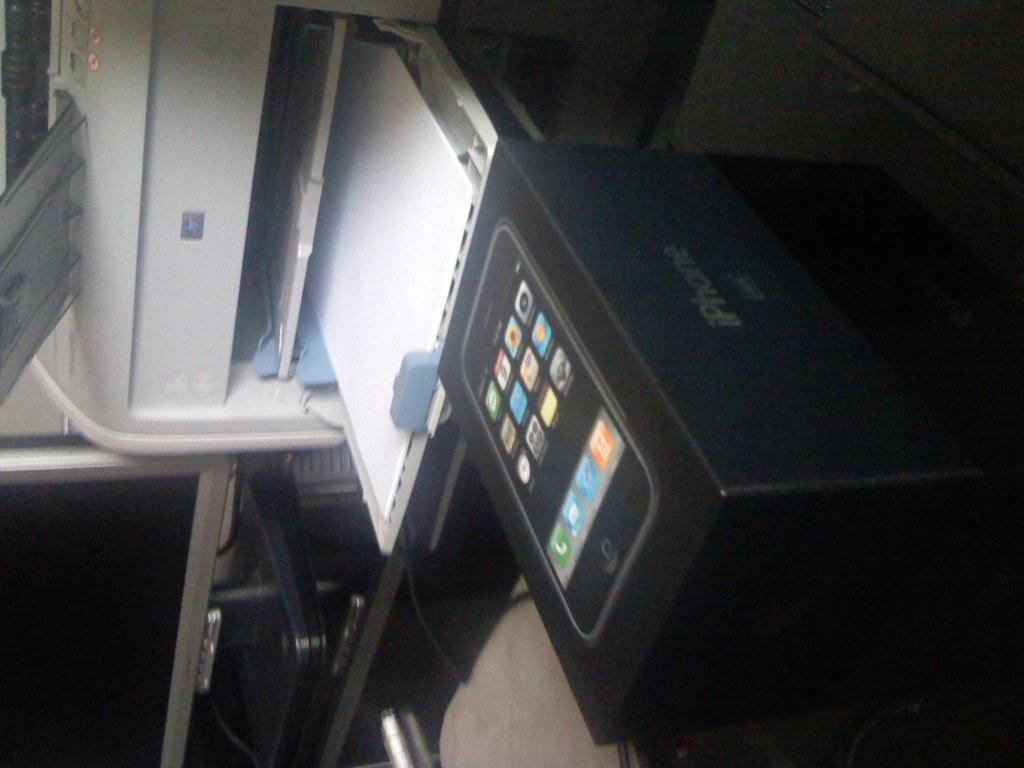<image>
Present a compact description of the photo's key features. An iPhone box sitting on a desk in front of a copier. 